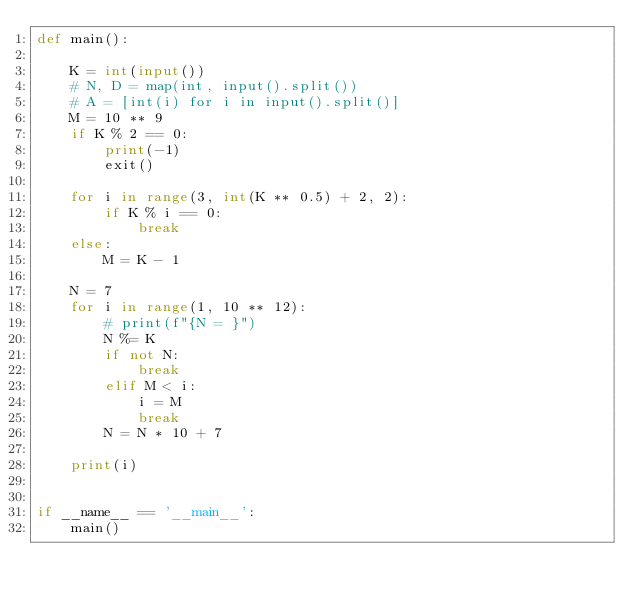Convert code to text. <code><loc_0><loc_0><loc_500><loc_500><_Python_>def main():

    K = int(input())
    # N, D = map(int, input().split())
    # A = [int(i) for i in input().split()]
    M = 10 ** 9
    if K % 2 == 0:
        print(-1)
        exit()

    for i in range(3, int(K ** 0.5) + 2, 2):
        if K % i == 0:
            break
    else:
        M = K - 1

    N = 7
    for i in range(1, 10 ** 12):
        # print(f"{N = }")
        N %= K
        if not N:
            break
        elif M < i:
            i = M
            break
        N = N * 10 + 7

    print(i)


if __name__ == '__main__':
    main()</code> 